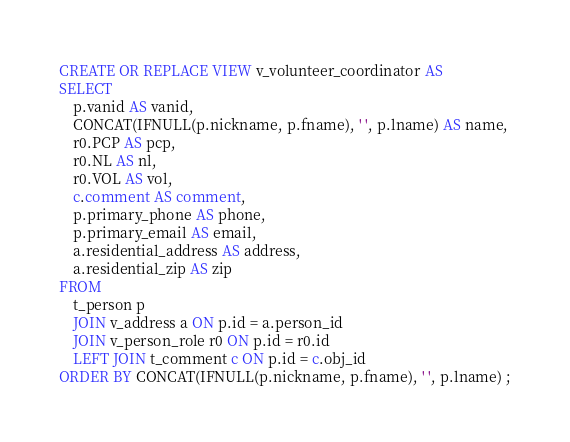<code> <loc_0><loc_0><loc_500><loc_500><_SQL_>CREATE OR REPLACE VIEW v_volunteer_coordinator AS
SELECT 
    p.vanid AS vanid,
    CONCAT(IFNULL(p.nickname, p.fname), ' ', p.lname) AS name,
    r0.PCP AS pcp,
    r0.NL AS nl,
    r0.VOL AS vol,
    c.comment AS comment,
    p.primary_phone AS phone,
    p.primary_email AS email,
    a.residential_address AS address,
    a.residential_zip AS zip
FROM
    t_person p
    JOIN v_address a ON p.id = a.person_id
    JOIN v_person_role r0 ON p.id = r0.id
    LEFT JOIN t_comment c ON p.id = c.obj_id
ORDER BY CONCAT(IFNULL(p.nickname, p.fname), ' ', p.lname) ;</code> 